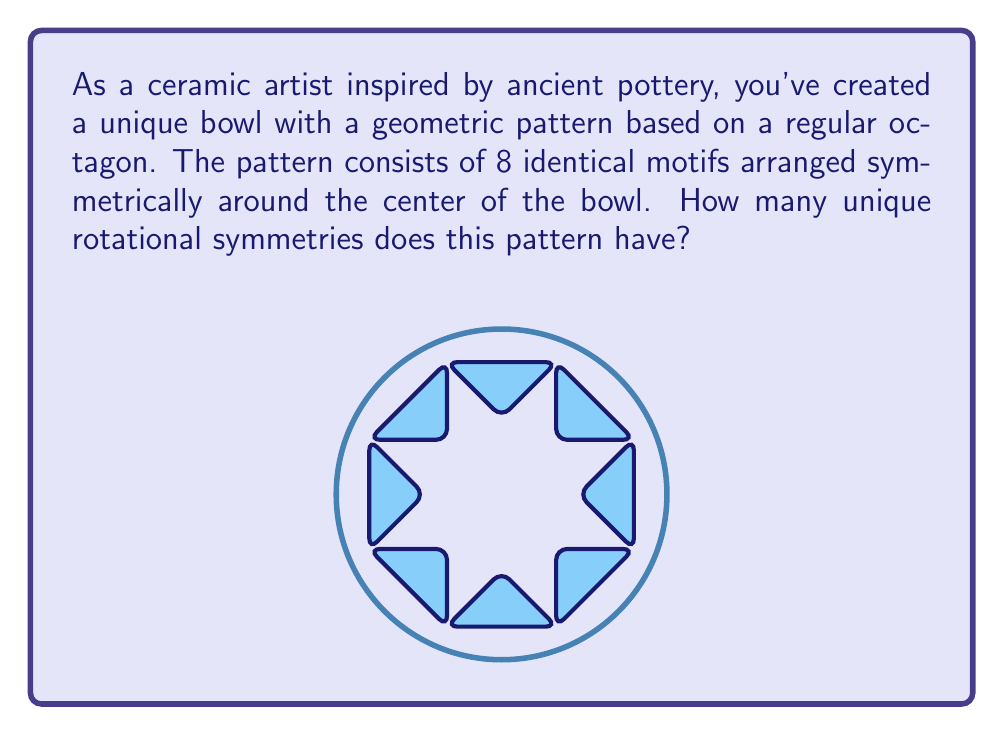Give your solution to this math problem. To determine the number of unique rotational symmetries, we need to consider the following steps:

1) First, recall that a rotational symmetry is a rotation that maps the pattern onto itself, leaving it unchanged.

2) In this case, we have a pattern based on a regular octagon, which has 8-fold rotational symmetry.

3) The number of unique rotational symmetries in a regular n-gon is equal to n. This is because we can rotate the pattern by multiples of $\frac{360°}{n}$ to obtain all possible symmetries.

4) For our octagonal pattern:
   - The angle of rotation for each symmetry is $\frac{360°}{8} = 45°$
   - The possible rotations are: 45°, 90°, 135°, 180°, 225°, 270°, 315°, and 360° (which is equivalent to 0° or no rotation)

5) Therefore, including the identity rotation (0° or 360°), we have 8 unique rotational symmetries.

6) Mathematically, we can express the rotational symmetry group of this pattern as:

   $$C_8 = \{r^0, r^1, r^2, r^3, r^4, r^5, r^6, r^7\}$$

   where $r$ represents a rotation by 45° and the exponent indicates the number of 45° rotations.

This group is cyclic and has order 8, confirming our count of 8 unique rotational symmetries.
Answer: 8 